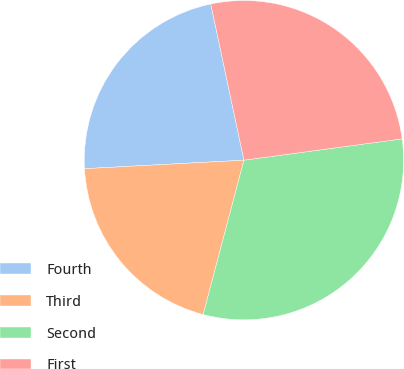<chart> <loc_0><loc_0><loc_500><loc_500><pie_chart><fcel>Fourth<fcel>Third<fcel>Second<fcel>First<nl><fcel>22.52%<fcel>20.04%<fcel>31.24%<fcel>26.2%<nl></chart> 